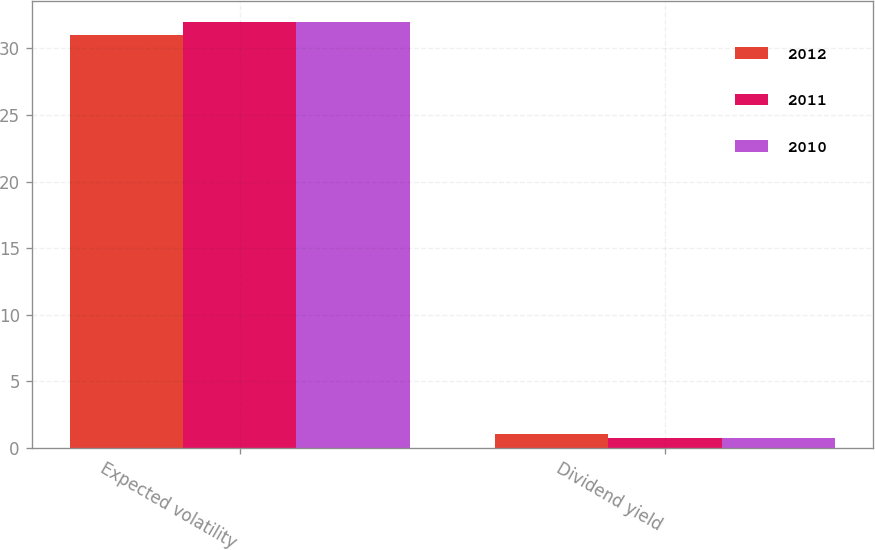Convert chart to OTSL. <chart><loc_0><loc_0><loc_500><loc_500><stacked_bar_chart><ecel><fcel>Expected volatility<fcel>Dividend yield<nl><fcel>2012<fcel>31<fcel>1.01<nl><fcel>2011<fcel>32<fcel>0.73<nl><fcel>2010<fcel>32<fcel>0.71<nl></chart> 